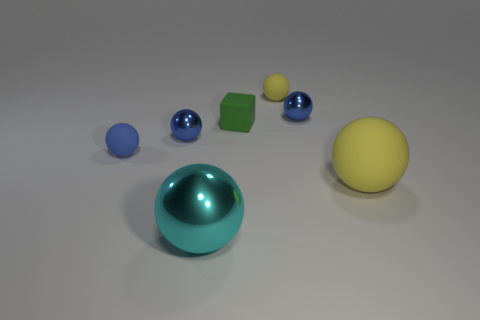Subtract all blue cubes. How many blue spheres are left? 3 Subtract 2 spheres. How many spheres are left? 4 Subtract all yellow matte spheres. How many spheres are left? 4 Subtract all cyan balls. How many balls are left? 5 Subtract all purple spheres. Subtract all yellow blocks. How many spheres are left? 6 Add 3 small yellow shiny blocks. How many objects exist? 10 Subtract all spheres. How many objects are left? 1 Add 6 matte objects. How many matte objects exist? 10 Subtract 0 gray cylinders. How many objects are left? 7 Subtract all blue metallic spheres. Subtract all small green matte objects. How many objects are left? 4 